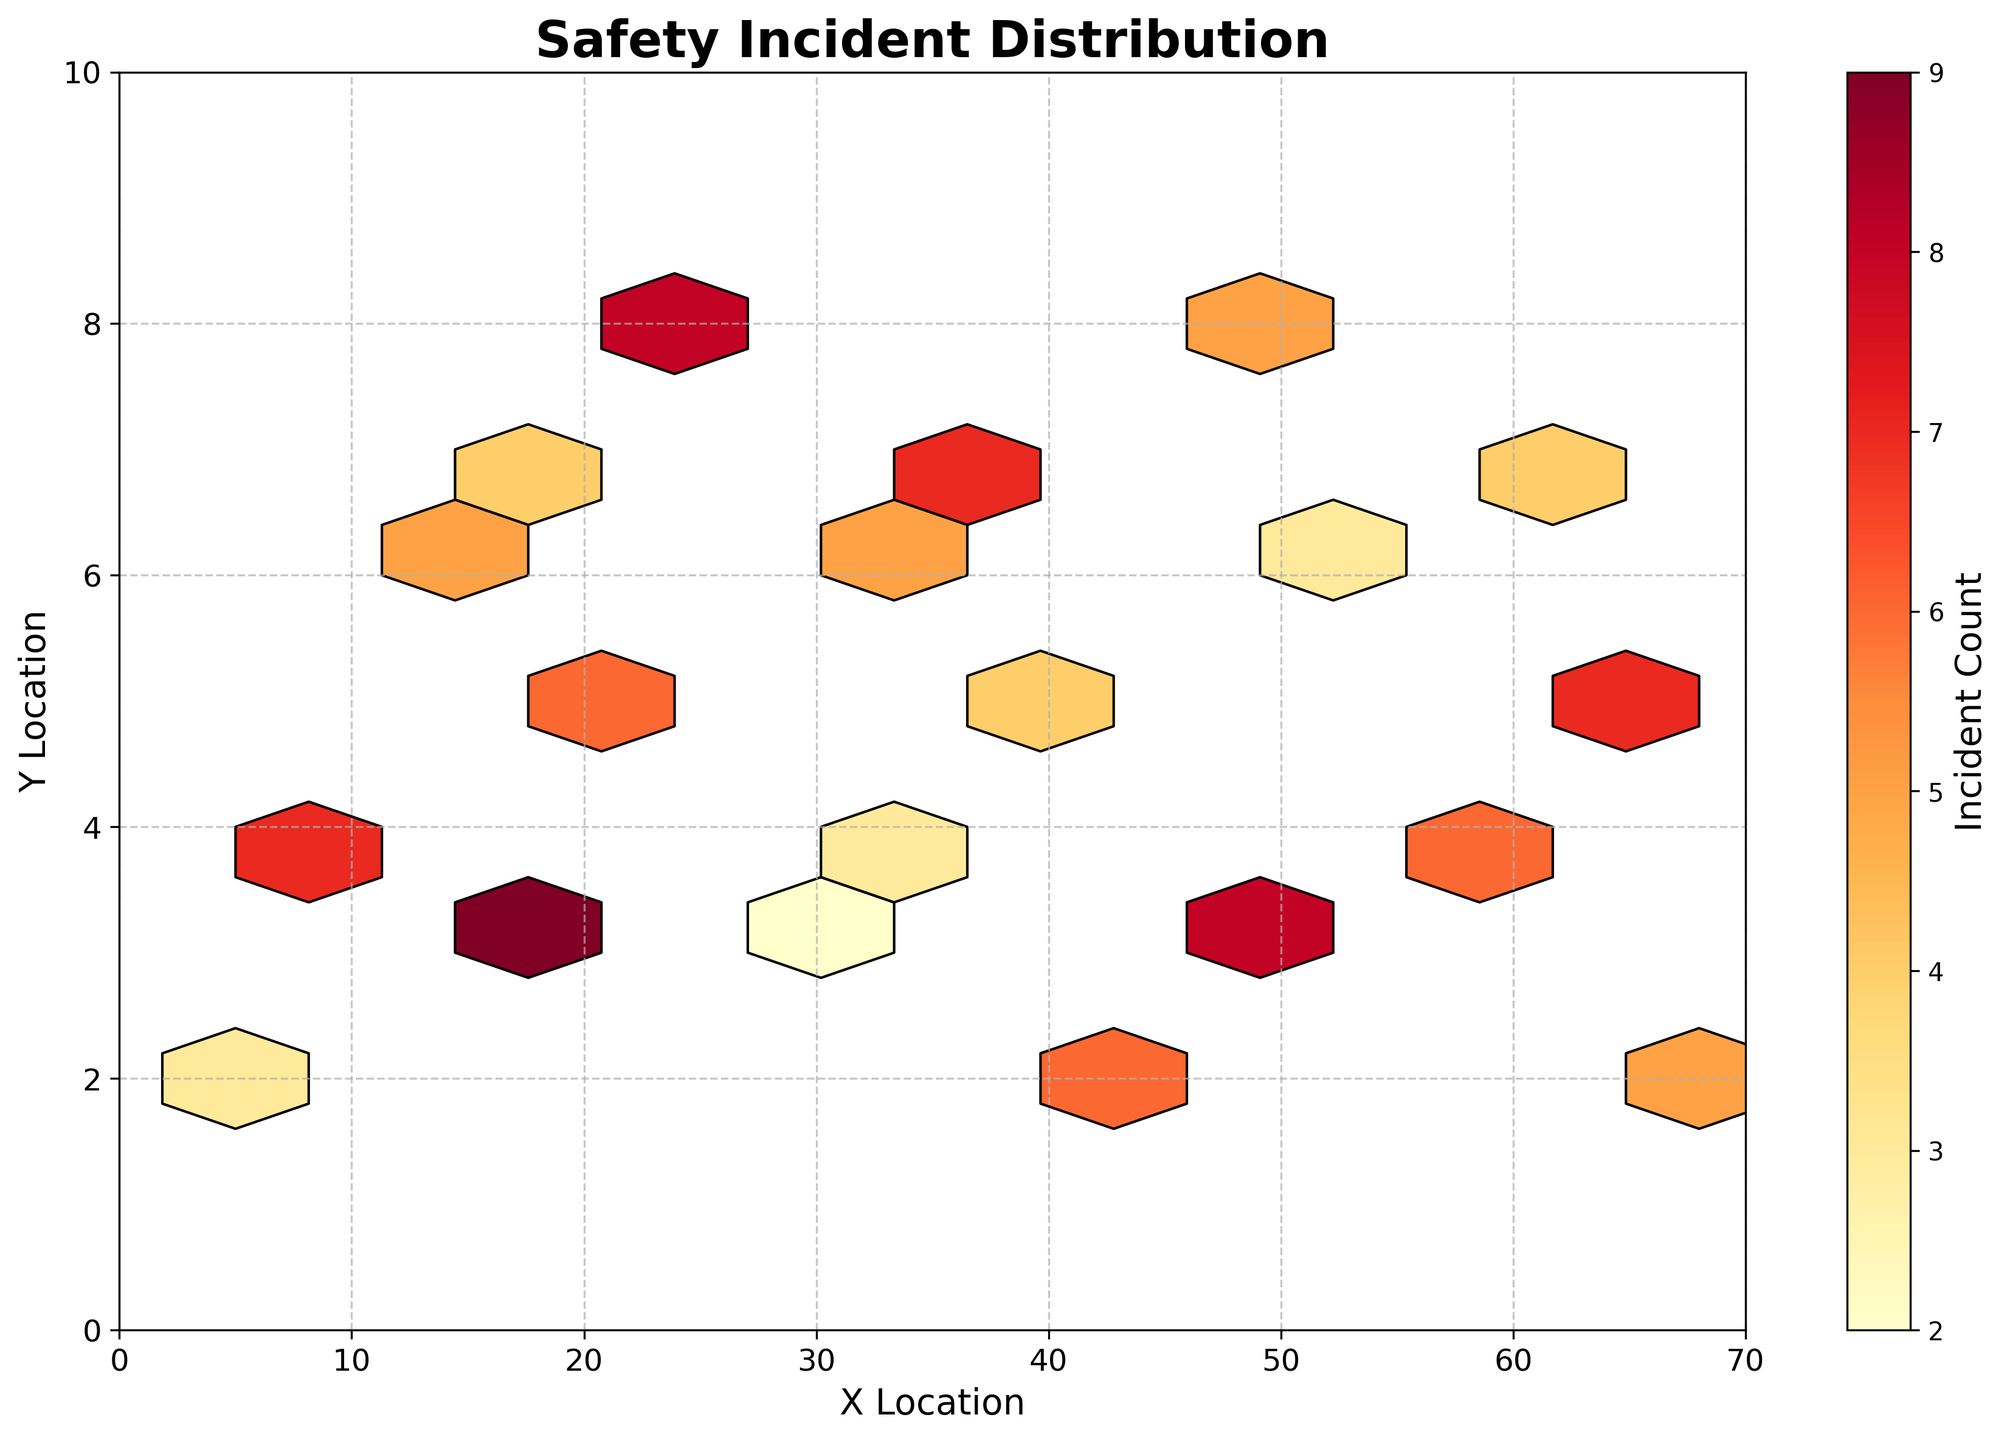What is the color of the hexagons with the highest incident count? The hexagons with the highest incident count are represented by the darkest color on the color scale used in the plot. In this case, the color corresponds to a dark red shade.
Answer: Dark red What is the title of the hexbin plot? The title of the hexbin plot is located at the top of the figure and it reads "Safety Incident Distribution".
Answer: Safety Incident Distribution Where are the most safety incidents reported on the premises? The hexagons with the highest counts (darkest colors) are concentrated around the x-location of approximately 52 and y-location of approximately 3.
Answer: Around (52, 3) How many hexagons have the highest incident count? By observing the color bar and the darkest color on the hexbin plot, there are three hexagons that have the highest incident count.
Answer: Three hexagons What is the range of the x-axis and y-axis? The x-axis ranges from 0 to 70, and the y-axis ranges from 0 to 10, as indicated by the axis labels and ticks.
Answer: x-axis: 0 to 70, y-axis: 0 to 10 What locations have the lowest incident counts? The hexagons with the lightest colors indicate the lowest incident counts, which occur around locations like (28, 3) and (5, 2).
Answer: (28, 3) and (5, 2) What is the average incident count in this plot? To find the average, sum all the incident counts and divide by the number of hexagons. Sum = 3 + 7 + 5 + 9 + 4 + 6 + 8 + 2 + 5 + 3 + 7 + 4 + 6 + 5 + 8 + 3 + 6 + 4 + 7 + 5 = 109. There are 20 hexagons, so the average is 109 / 20.
Answer: 5.45 Which x-location has the highest frequency of reported incidents? The x-location with the highest frequency of reported incidents is around 52, as indicated by a hexagon with a dark color representing high incident counts.
Answer: 52 Compare the incident counts at (25, 8) and (42, 5). Which location has more incidents? By observing the color intensity, (25, 8) has a higher count since the hexagon is darker compared to the hexagon at (42, 5).
Answer: (25, 8) What can be inferred about safety incidents around locations with a higher y-coordinate (closer to 10)? There are fewer and lighter hexagons at higher y-coordinates, indicating that fewer incidents are reported in those areas.
Answer: Fewer incidents 